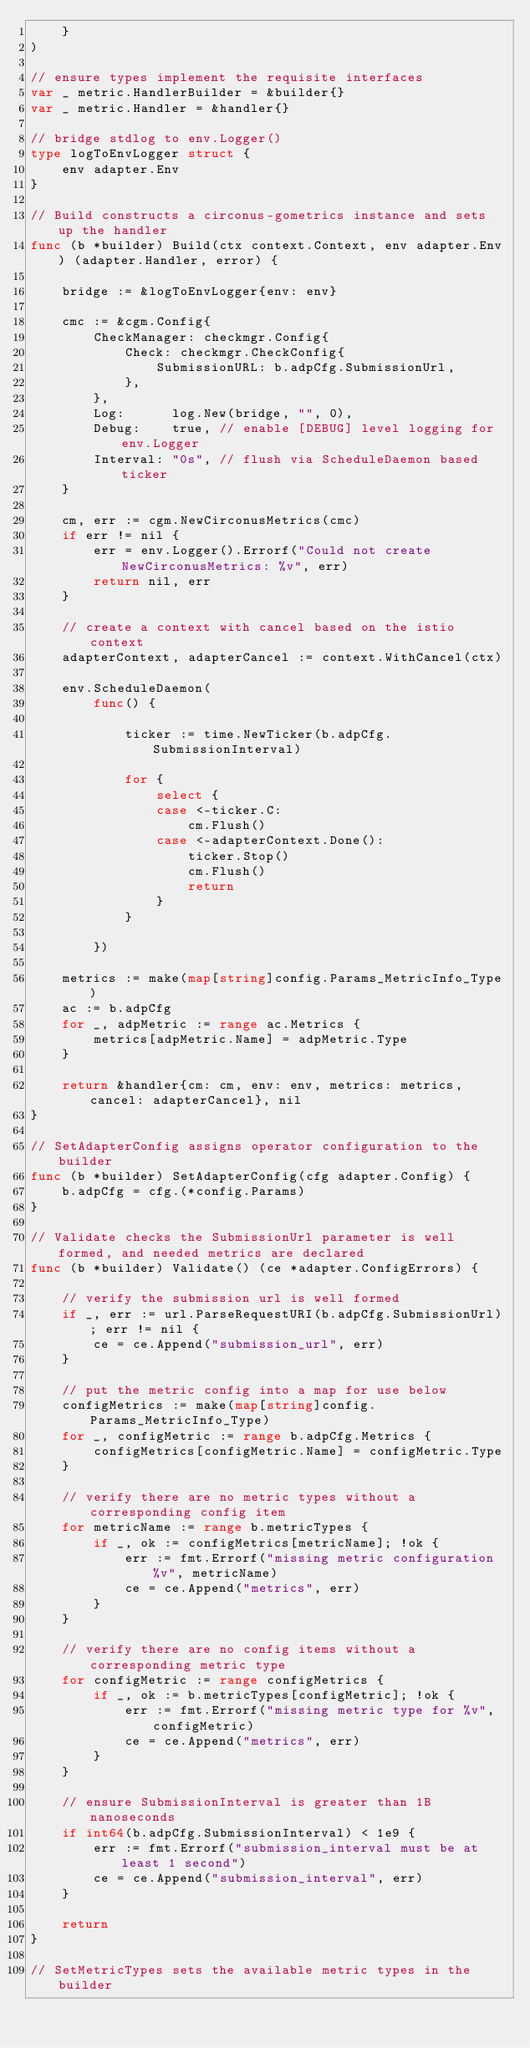Convert code to text. <code><loc_0><loc_0><loc_500><loc_500><_Go_>	}
)

// ensure types implement the requisite interfaces
var _ metric.HandlerBuilder = &builder{}
var _ metric.Handler = &handler{}

// bridge stdlog to env.Logger()
type logToEnvLogger struct {
	env adapter.Env
}

// Build constructs a circonus-gometrics instance and sets up the handler
func (b *builder) Build(ctx context.Context, env adapter.Env) (adapter.Handler, error) {

	bridge := &logToEnvLogger{env: env}

	cmc := &cgm.Config{
		CheckManager: checkmgr.Config{
			Check: checkmgr.CheckConfig{
				SubmissionURL: b.adpCfg.SubmissionUrl,
			},
		},
		Log:      log.New(bridge, "", 0),
		Debug:    true, // enable [DEBUG] level logging for env.Logger
		Interval: "0s", // flush via ScheduleDaemon based ticker
	}

	cm, err := cgm.NewCirconusMetrics(cmc)
	if err != nil {
		err = env.Logger().Errorf("Could not create NewCirconusMetrics: %v", err)
		return nil, err
	}

	// create a context with cancel based on the istio context
	adapterContext, adapterCancel := context.WithCancel(ctx)

	env.ScheduleDaemon(
		func() {

			ticker := time.NewTicker(b.adpCfg.SubmissionInterval)

			for {
				select {
				case <-ticker.C:
					cm.Flush()
				case <-adapterContext.Done():
					ticker.Stop()
					cm.Flush()
					return
				}
			}

		})

	metrics := make(map[string]config.Params_MetricInfo_Type)
	ac := b.adpCfg
	for _, adpMetric := range ac.Metrics {
		metrics[adpMetric.Name] = adpMetric.Type
	}

	return &handler{cm: cm, env: env, metrics: metrics, cancel: adapterCancel}, nil
}

// SetAdapterConfig assigns operator configuration to the builder
func (b *builder) SetAdapterConfig(cfg adapter.Config) {
	b.adpCfg = cfg.(*config.Params)
}

// Validate checks the SubmissionUrl parameter is well formed, and needed metrics are declared
func (b *builder) Validate() (ce *adapter.ConfigErrors) {

	// verify the submission url is well formed
	if _, err := url.ParseRequestURI(b.adpCfg.SubmissionUrl); err != nil {
		ce = ce.Append("submission_url", err)
	}

	// put the metric config into a map for use below
	configMetrics := make(map[string]config.Params_MetricInfo_Type)
	for _, configMetric := range b.adpCfg.Metrics {
		configMetrics[configMetric.Name] = configMetric.Type
	}

	// verify there are no metric types without a corresponding config item
	for metricName := range b.metricTypes {
		if _, ok := configMetrics[metricName]; !ok {
			err := fmt.Errorf("missing metric configuration %v", metricName)
			ce = ce.Append("metrics", err)
		}
	}

	// verify there are no config items without a corresponding metric type
	for configMetric := range configMetrics {
		if _, ok := b.metricTypes[configMetric]; !ok {
			err := fmt.Errorf("missing metric type for %v", configMetric)
			ce = ce.Append("metrics", err)
		}
	}

	// ensure SubmissionInterval is greater than 1B nanoseconds
	if int64(b.adpCfg.SubmissionInterval) < 1e9 {
		err := fmt.Errorf("submission_interval must be at least 1 second")
		ce = ce.Append("submission_interval", err)
	}

	return
}

// SetMetricTypes sets the available metric types in the builder</code> 